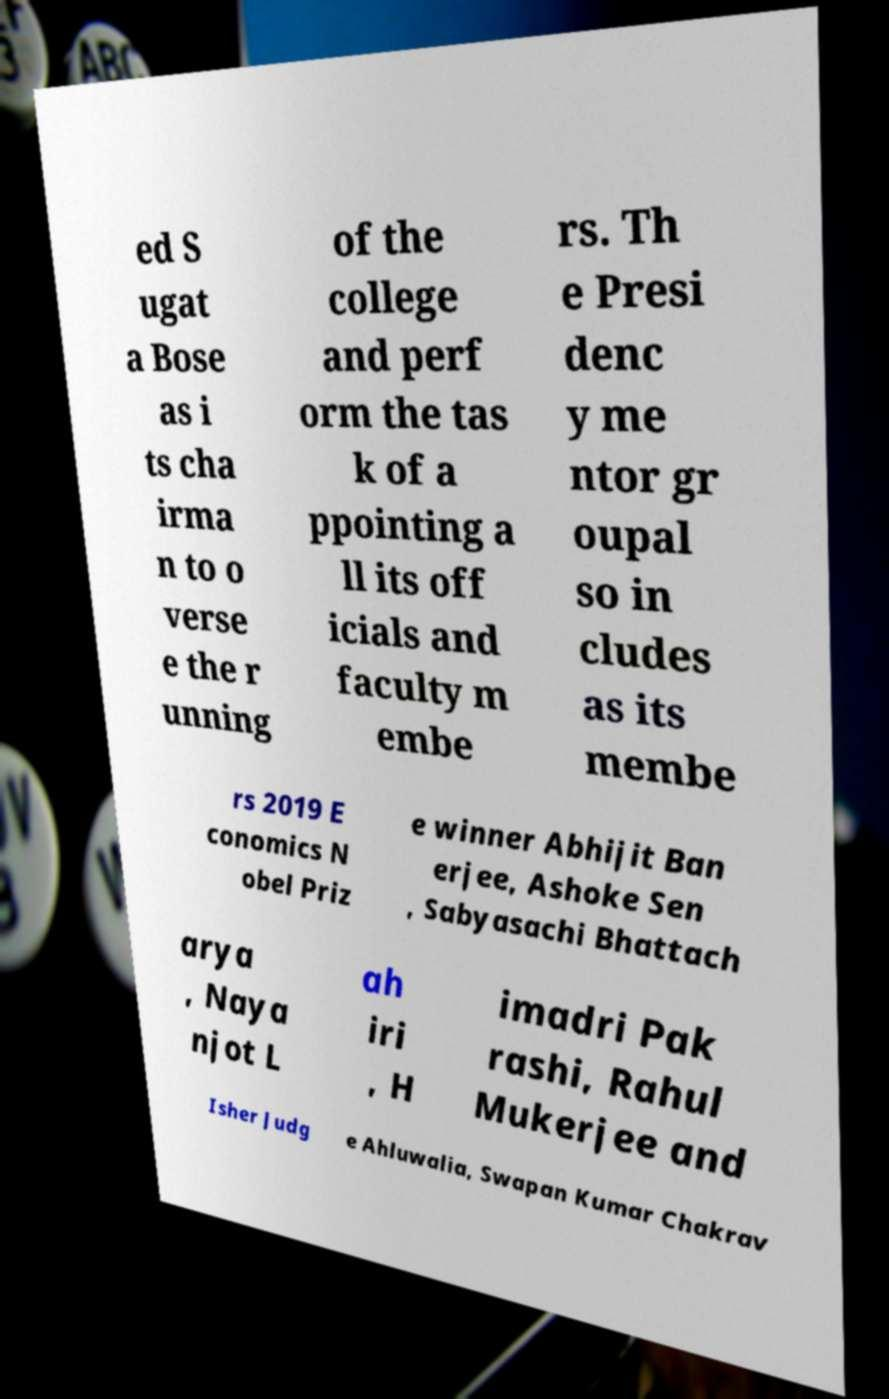Could you assist in decoding the text presented in this image and type it out clearly? ed S ugat a Bose as i ts cha irma n to o verse e the r unning of the college and perf orm the tas k of a ppointing a ll its off icials and faculty m embe rs. Th e Presi denc y me ntor gr oupal so in cludes as its membe rs 2019 E conomics N obel Priz e winner Abhijit Ban erjee, Ashoke Sen , Sabyasachi Bhattach arya , Naya njot L ah iri , H imadri Pak rashi, Rahul Mukerjee and Isher Judg e Ahluwalia, Swapan Kumar Chakrav 